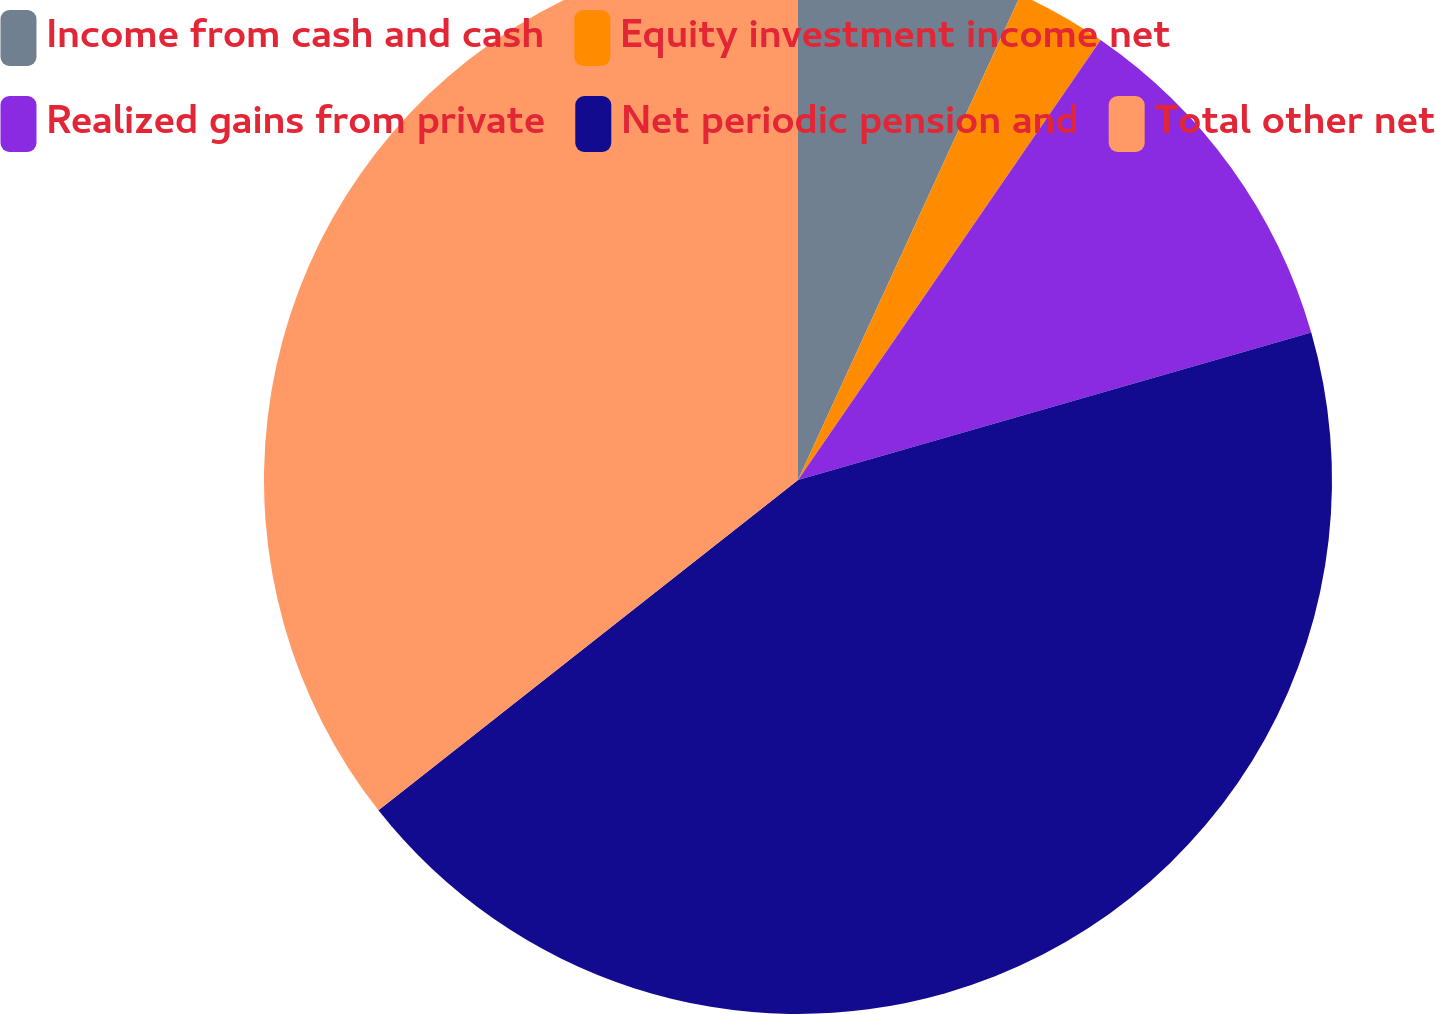Convert chart. <chart><loc_0><loc_0><loc_500><loc_500><pie_chart><fcel>Income from cash and cash<fcel>Equity investment income net<fcel>Realized gains from private<fcel>Net periodic pension and<fcel>Total other net<nl><fcel>6.85%<fcel>2.74%<fcel>10.96%<fcel>43.84%<fcel>35.62%<nl></chart> 